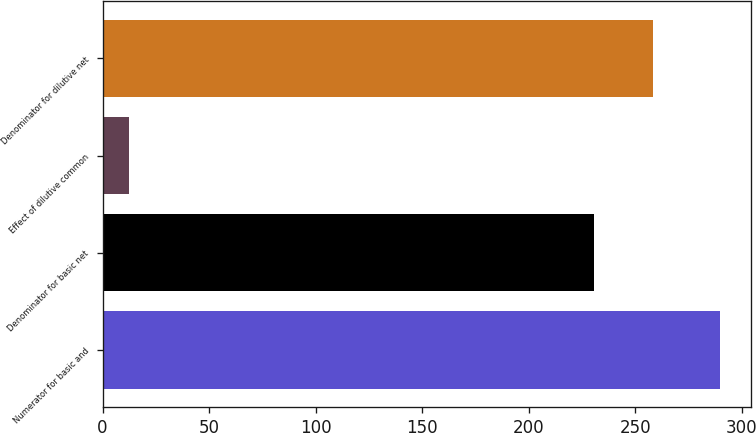Convert chart. <chart><loc_0><loc_0><loc_500><loc_500><bar_chart><fcel>Numerator for basic and<fcel>Denominator for basic net<fcel>Effect of dilutive common<fcel>Denominator for dilutive net<nl><fcel>289.7<fcel>230.7<fcel>12.5<fcel>258.42<nl></chart> 